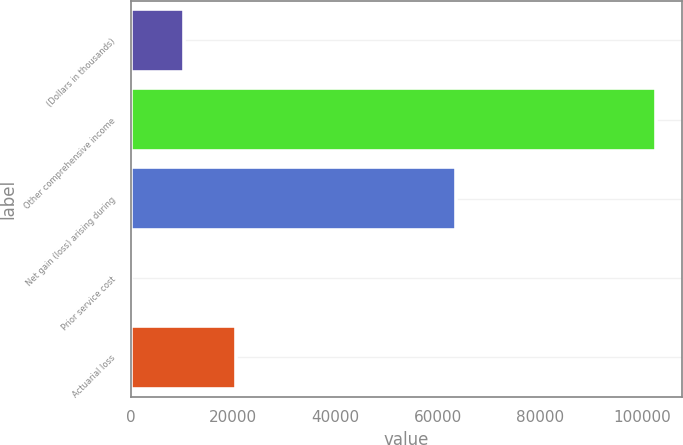<chart> <loc_0><loc_0><loc_500><loc_500><bar_chart><fcel>(Dollars in thousands)<fcel>Other comprehensive income<fcel>Net gain (loss) arising during<fcel>Prior service cost<fcel>Actuarial loss<nl><fcel>10313.3<fcel>102692<fcel>63651.3<fcel>49<fcel>20577.6<nl></chart> 